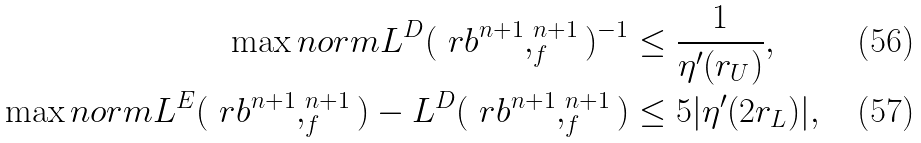<formula> <loc_0><loc_0><loc_500><loc_500>\max n o r m { L ^ { D } ( \ r b ^ { n + 1 } , _ { f } ^ { n + 1 } ) ^ { - 1 } } & \leq \frac { 1 } { \eta ^ { \prime } ( r _ { U } ) } , \\ \max n o r m { L ^ { E } ( \ r b ^ { n + 1 } , _ { f } ^ { n + 1 } ) - L ^ { D } ( \ r b ^ { n + 1 } , _ { f } ^ { n + 1 } ) } & \leq 5 | \eta ^ { \prime } ( 2 r _ { L } ) | ,</formula> 